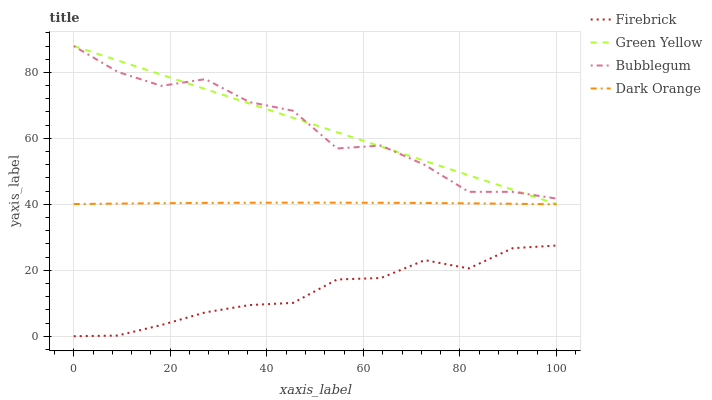Does Firebrick have the minimum area under the curve?
Answer yes or no. Yes. Does Green Yellow have the maximum area under the curve?
Answer yes or no. Yes. Does Green Yellow have the minimum area under the curve?
Answer yes or no. No. Does Firebrick have the maximum area under the curve?
Answer yes or no. No. Is Green Yellow the smoothest?
Answer yes or no. Yes. Is Bubblegum the roughest?
Answer yes or no. Yes. Is Firebrick the smoothest?
Answer yes or no. No. Is Firebrick the roughest?
Answer yes or no. No. Does Firebrick have the lowest value?
Answer yes or no. Yes. Does Green Yellow have the lowest value?
Answer yes or no. No. Does Bubblegum have the highest value?
Answer yes or no. Yes. Does Firebrick have the highest value?
Answer yes or no. No. Is Firebrick less than Green Yellow?
Answer yes or no. Yes. Is Dark Orange greater than Firebrick?
Answer yes or no. Yes. Does Green Yellow intersect Bubblegum?
Answer yes or no. Yes. Is Green Yellow less than Bubblegum?
Answer yes or no. No. Is Green Yellow greater than Bubblegum?
Answer yes or no. No. Does Firebrick intersect Green Yellow?
Answer yes or no. No. 